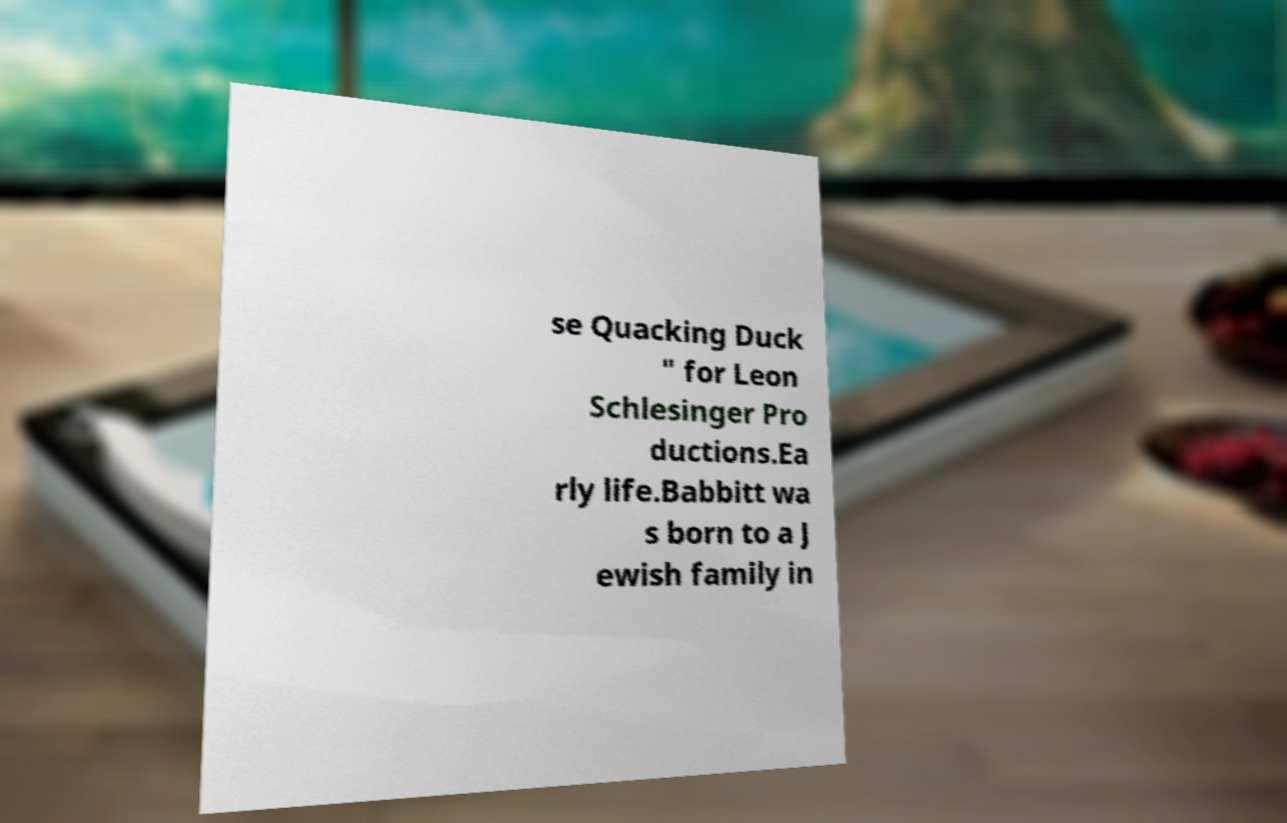Can you accurately transcribe the text from the provided image for me? se Quacking Duck " for Leon Schlesinger Pro ductions.Ea rly life.Babbitt wa s born to a J ewish family in 